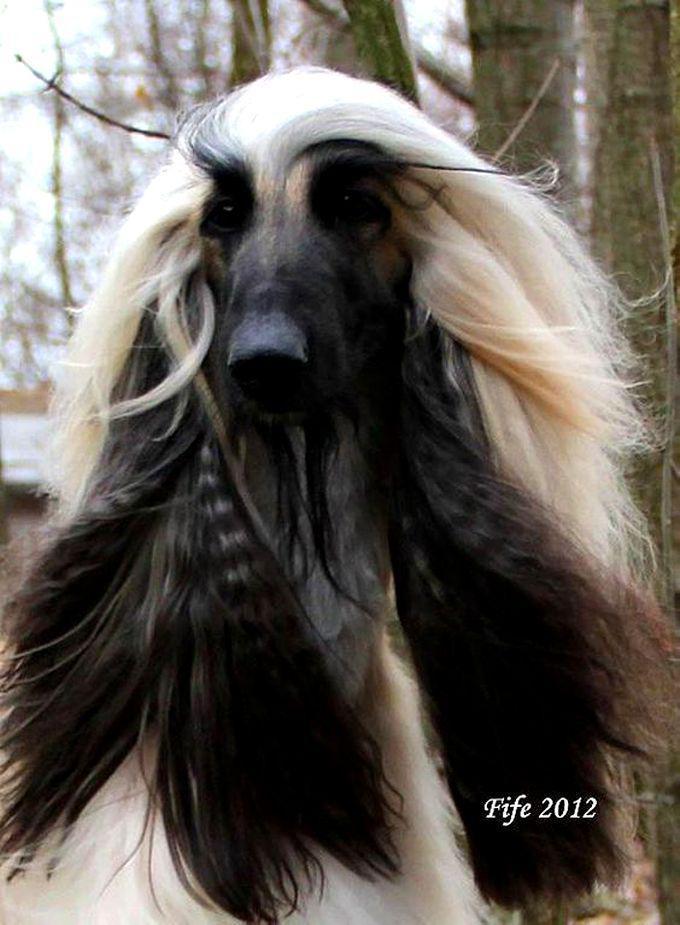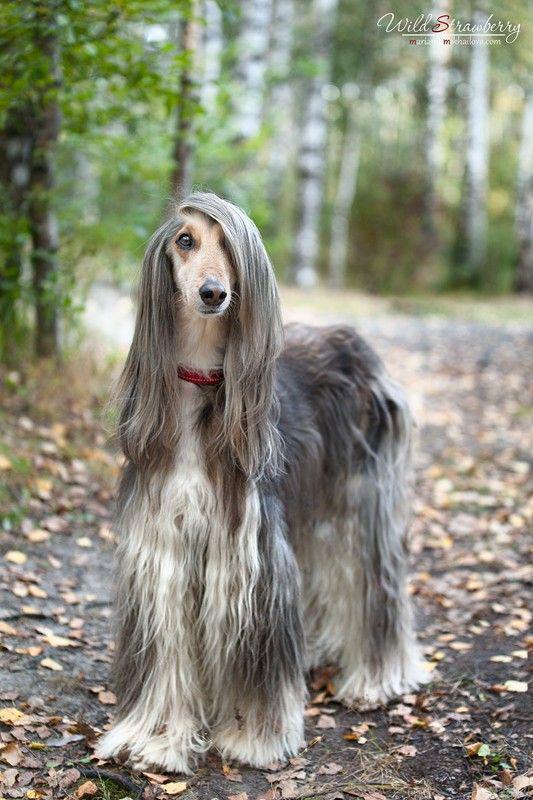The first image is the image on the left, the second image is the image on the right. Given the left and right images, does the statement "The right and left image contains the same number of dogs." hold true? Answer yes or no. Yes. The first image is the image on the left, the second image is the image on the right. Examine the images to the left and right. Is the description "There are no fewer than 3 dogs." accurate? Answer yes or no. No. 